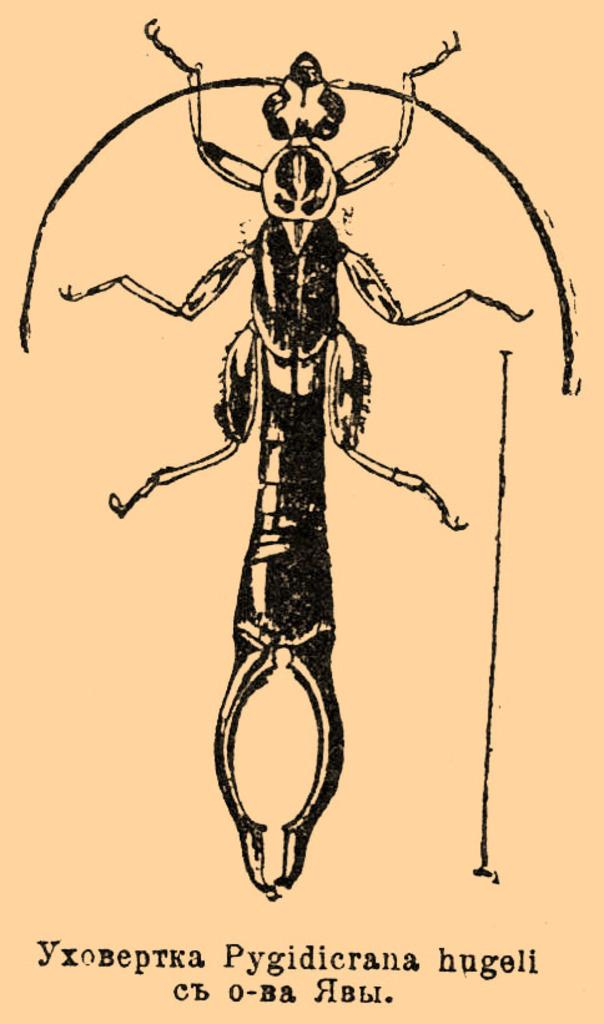What is featured in the image? There is a poster in the image. What is depicted on the poster? The poster contains a picture of an insect. Is there any text on the poster? There is text written at the bottom of the image. How many ants are crawling on the curtain in the image? There are no ants or curtains present in the image; it only features a poster with an insect and text. 